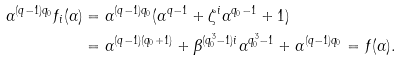<formula> <loc_0><loc_0><loc_500><loc_500>\alpha ^ { ( q - 1 ) q _ { 0 } } f _ { i } ( \alpha ) & = \alpha ^ { ( q - 1 ) q _ { 0 } } ( \alpha ^ { q - 1 } + \zeta ^ { i } \alpha ^ { q _ { 0 } - 1 } + 1 ) \\ & = \alpha ^ { ( q - 1 ) ( q _ { 0 } + 1 ) } + \beta ^ { ( q _ { 0 } ^ { 3 } - 1 ) i } \alpha ^ { q _ { 0 } ^ { 3 } - 1 } + \alpha ^ { ( q - 1 ) q _ { 0 } } = f ( \alpha ) .</formula> 